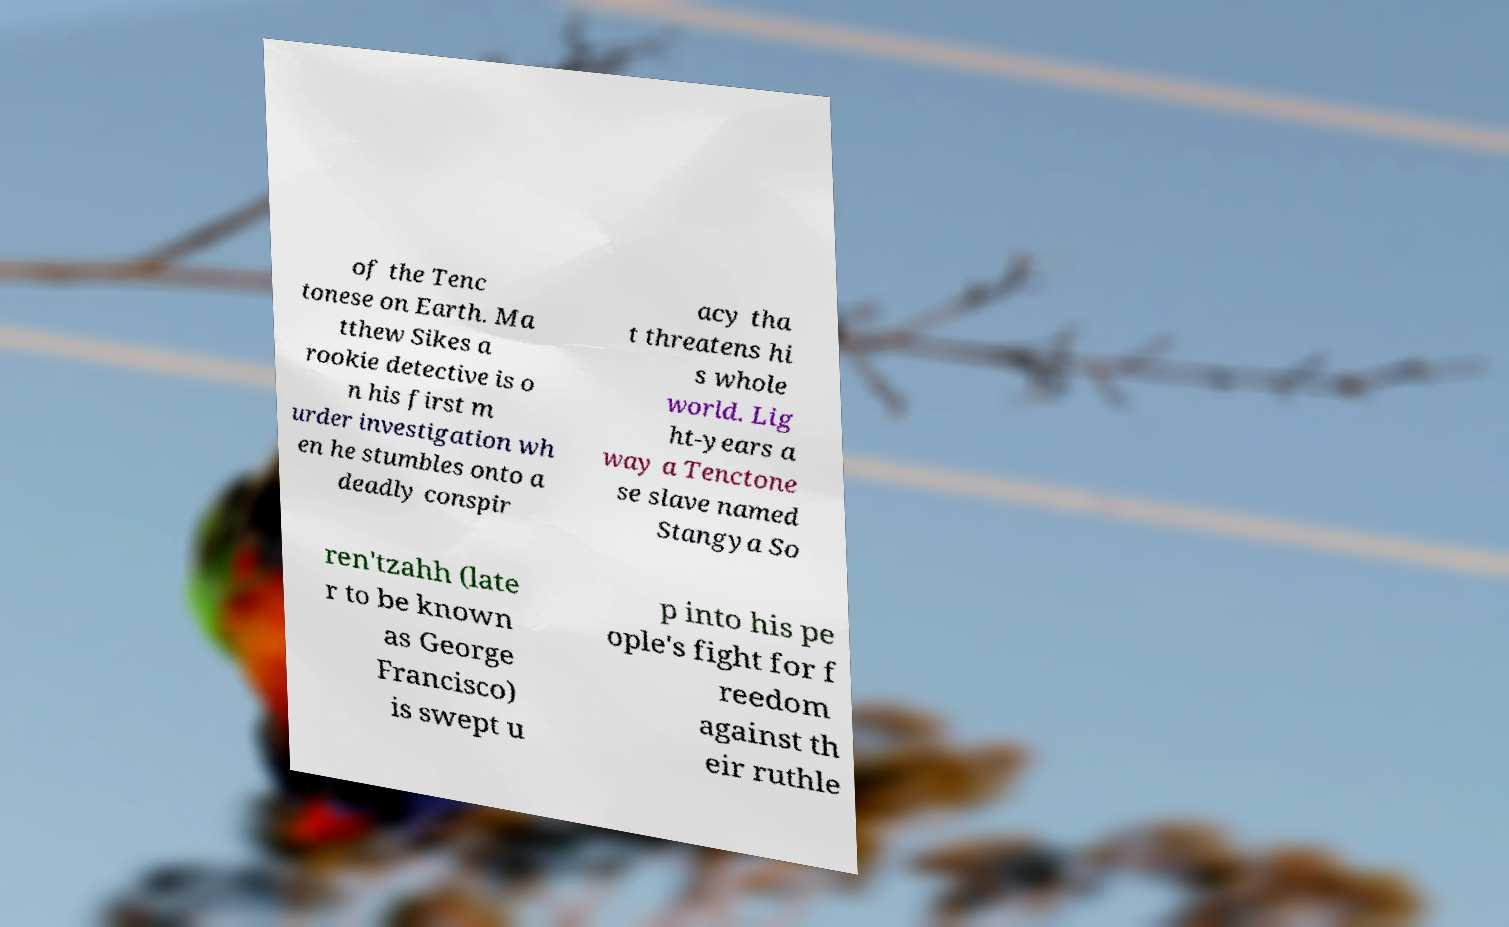I need the written content from this picture converted into text. Can you do that? of the Tenc tonese on Earth. Ma tthew Sikes a rookie detective is o n his first m urder investigation wh en he stumbles onto a deadly conspir acy tha t threatens hi s whole world. Lig ht-years a way a Tenctone se slave named Stangya So ren'tzahh (late r to be known as George Francisco) is swept u p into his pe ople's fight for f reedom against th eir ruthle 